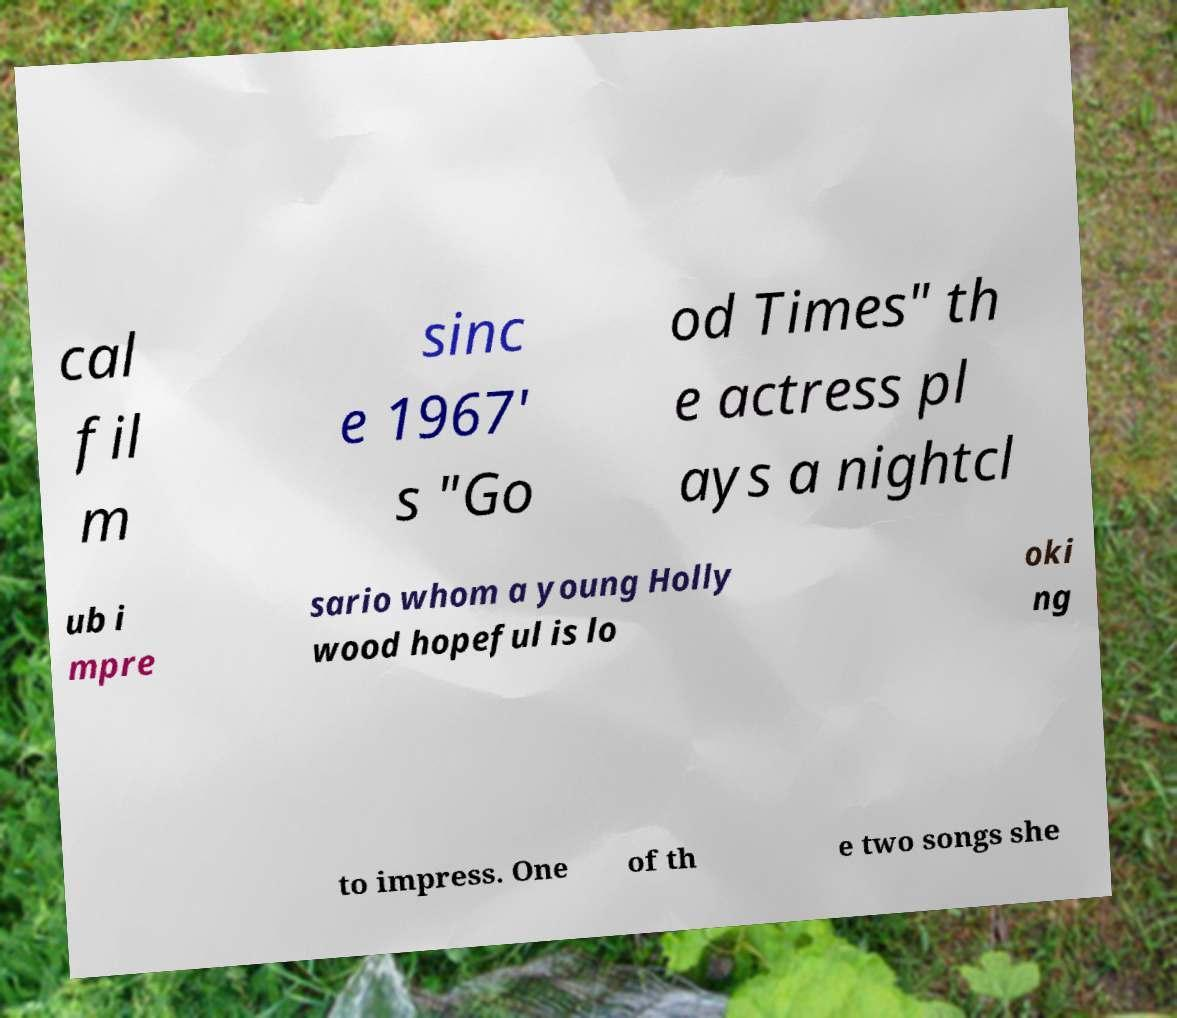Could you extract and type out the text from this image? cal fil m sinc e 1967' s "Go od Times" th e actress pl ays a nightcl ub i mpre sario whom a young Holly wood hopeful is lo oki ng to impress. One of th e two songs she 